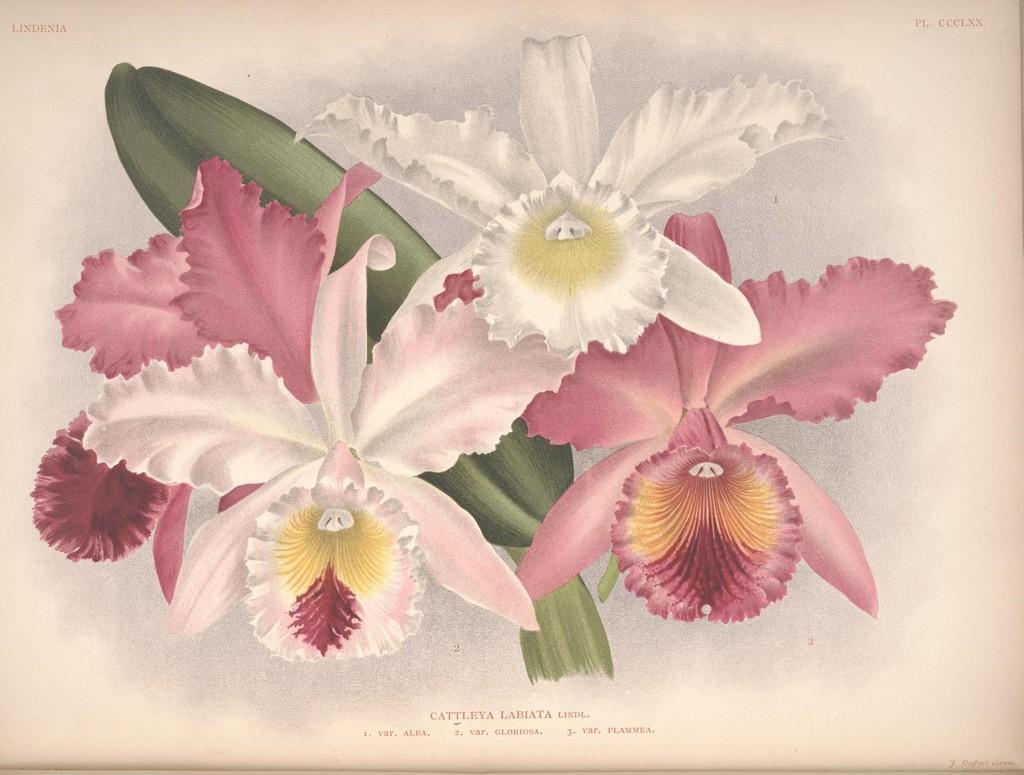Please provide a concise description of this image. In this picture we can see an art on the paper and on the paper it is written something. 